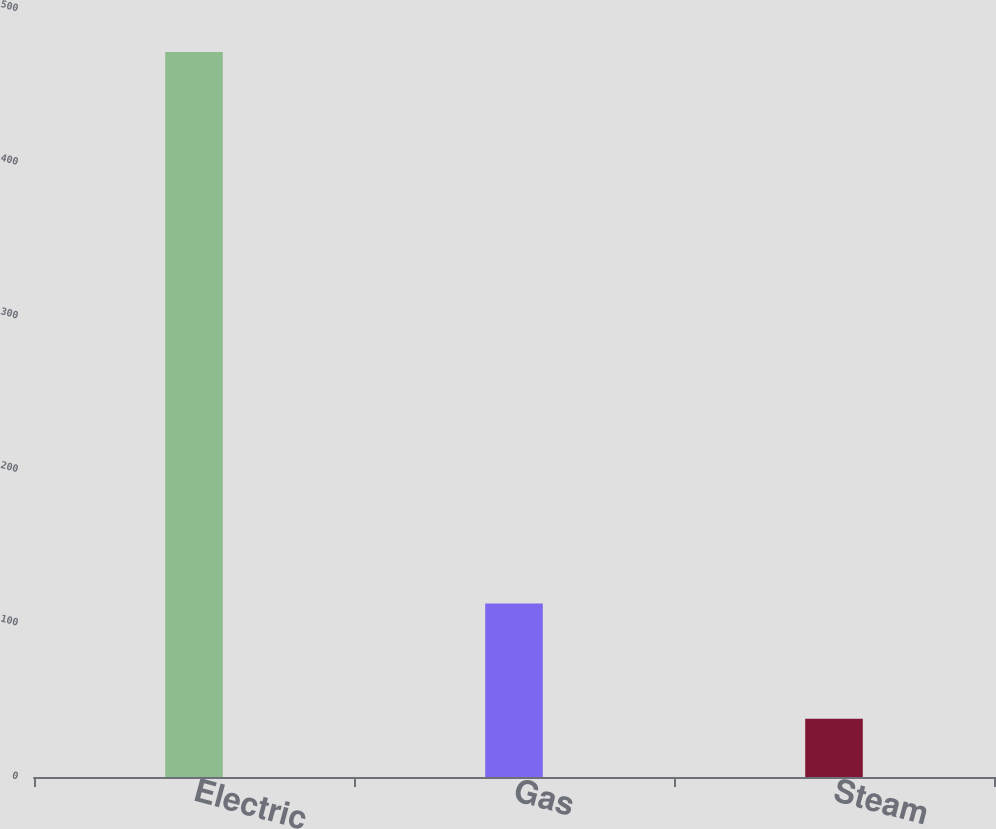Convert chart. <chart><loc_0><loc_0><loc_500><loc_500><bar_chart><fcel>Electric<fcel>Gas<fcel>Steam<nl><fcel>472<fcel>113<fcel>38<nl></chart> 